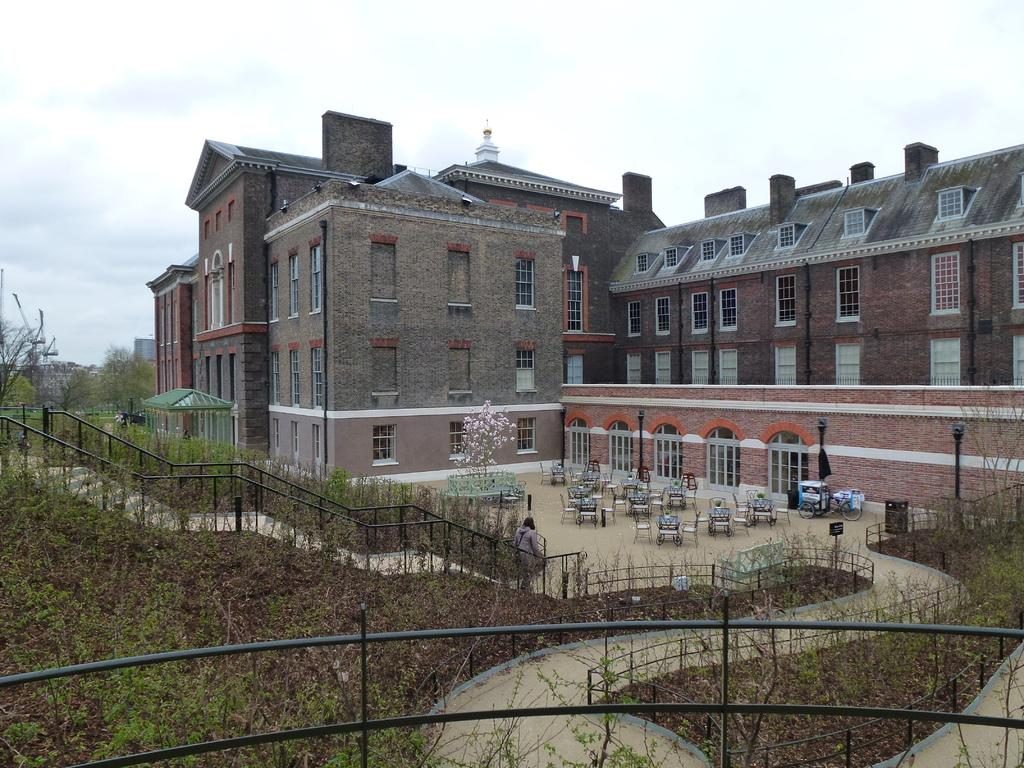What is the main structure in the center of the image? There is a building in the center of the image. What objects are present at the bottom of the image? Chairs, tables, plants, and fencing are visible at the bottom of the image. What type of vegetation is present at the bottom of the image? Grass is visible at the bottom of the image. What can be seen in the background of the image? The sky and clouds are visible in the background of the image. What type of plastic material is used to make the cherry in the image? There is no cherry present in the image, so it is not possible to determine the type of plastic material used. 